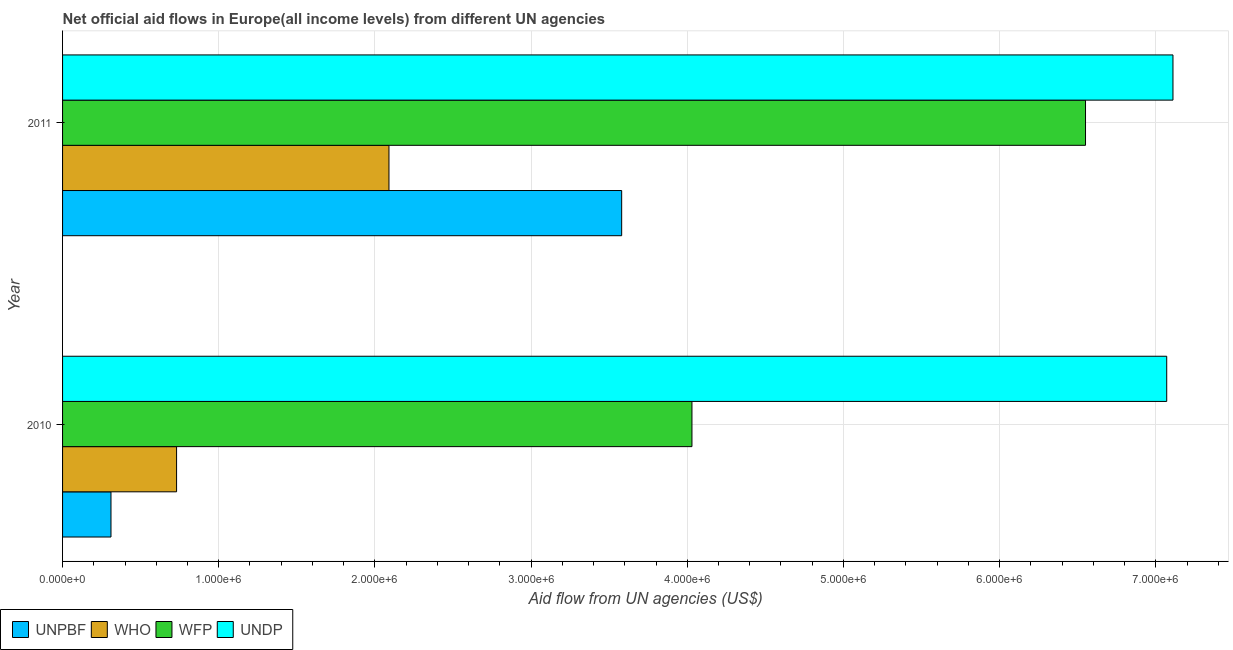How many groups of bars are there?
Your answer should be compact. 2. Are the number of bars per tick equal to the number of legend labels?
Your response must be concise. Yes. Are the number of bars on each tick of the Y-axis equal?
Offer a terse response. Yes. How many bars are there on the 2nd tick from the top?
Your answer should be very brief. 4. What is the label of the 1st group of bars from the top?
Your response must be concise. 2011. What is the amount of aid given by undp in 2011?
Your answer should be very brief. 7.11e+06. Across all years, what is the maximum amount of aid given by undp?
Provide a short and direct response. 7.11e+06. Across all years, what is the minimum amount of aid given by undp?
Provide a short and direct response. 7.07e+06. In which year was the amount of aid given by wfp maximum?
Provide a short and direct response. 2011. In which year was the amount of aid given by wfp minimum?
Make the answer very short. 2010. What is the total amount of aid given by unpbf in the graph?
Provide a short and direct response. 3.89e+06. What is the difference between the amount of aid given by who in 2010 and that in 2011?
Give a very brief answer. -1.36e+06. What is the difference between the amount of aid given by unpbf in 2010 and the amount of aid given by who in 2011?
Offer a very short reply. -1.78e+06. What is the average amount of aid given by undp per year?
Offer a terse response. 7.09e+06. In the year 2011, what is the difference between the amount of aid given by wfp and amount of aid given by unpbf?
Provide a short and direct response. 2.97e+06. In how many years, is the amount of aid given by who greater than 6800000 US$?
Make the answer very short. 0. What is the ratio of the amount of aid given by who in 2010 to that in 2011?
Provide a short and direct response. 0.35. Is the amount of aid given by unpbf in 2010 less than that in 2011?
Your response must be concise. Yes. What does the 2nd bar from the top in 2010 represents?
Ensure brevity in your answer.  WFP. What does the 3rd bar from the bottom in 2011 represents?
Your answer should be very brief. WFP. Is it the case that in every year, the sum of the amount of aid given by unpbf and amount of aid given by who is greater than the amount of aid given by wfp?
Give a very brief answer. No. Does the graph contain any zero values?
Your answer should be compact. No. Does the graph contain grids?
Ensure brevity in your answer.  Yes. Where does the legend appear in the graph?
Your answer should be compact. Bottom left. How many legend labels are there?
Make the answer very short. 4. How are the legend labels stacked?
Your answer should be compact. Horizontal. What is the title of the graph?
Offer a terse response. Net official aid flows in Europe(all income levels) from different UN agencies. Does "CO2 damage" appear as one of the legend labels in the graph?
Give a very brief answer. No. What is the label or title of the X-axis?
Provide a short and direct response. Aid flow from UN agencies (US$). What is the Aid flow from UN agencies (US$) in WHO in 2010?
Your response must be concise. 7.30e+05. What is the Aid flow from UN agencies (US$) in WFP in 2010?
Provide a succinct answer. 4.03e+06. What is the Aid flow from UN agencies (US$) in UNDP in 2010?
Your answer should be compact. 7.07e+06. What is the Aid flow from UN agencies (US$) of UNPBF in 2011?
Give a very brief answer. 3.58e+06. What is the Aid flow from UN agencies (US$) in WHO in 2011?
Ensure brevity in your answer.  2.09e+06. What is the Aid flow from UN agencies (US$) in WFP in 2011?
Your answer should be compact. 6.55e+06. What is the Aid flow from UN agencies (US$) of UNDP in 2011?
Keep it short and to the point. 7.11e+06. Across all years, what is the maximum Aid flow from UN agencies (US$) of UNPBF?
Your answer should be compact. 3.58e+06. Across all years, what is the maximum Aid flow from UN agencies (US$) in WHO?
Your answer should be very brief. 2.09e+06. Across all years, what is the maximum Aid flow from UN agencies (US$) of WFP?
Offer a terse response. 6.55e+06. Across all years, what is the maximum Aid flow from UN agencies (US$) in UNDP?
Ensure brevity in your answer.  7.11e+06. Across all years, what is the minimum Aid flow from UN agencies (US$) in WHO?
Make the answer very short. 7.30e+05. Across all years, what is the minimum Aid flow from UN agencies (US$) in WFP?
Ensure brevity in your answer.  4.03e+06. Across all years, what is the minimum Aid flow from UN agencies (US$) in UNDP?
Your answer should be compact. 7.07e+06. What is the total Aid flow from UN agencies (US$) of UNPBF in the graph?
Keep it short and to the point. 3.89e+06. What is the total Aid flow from UN agencies (US$) in WHO in the graph?
Ensure brevity in your answer.  2.82e+06. What is the total Aid flow from UN agencies (US$) in WFP in the graph?
Provide a short and direct response. 1.06e+07. What is the total Aid flow from UN agencies (US$) in UNDP in the graph?
Keep it short and to the point. 1.42e+07. What is the difference between the Aid flow from UN agencies (US$) in UNPBF in 2010 and that in 2011?
Your answer should be very brief. -3.27e+06. What is the difference between the Aid flow from UN agencies (US$) of WHO in 2010 and that in 2011?
Your response must be concise. -1.36e+06. What is the difference between the Aid flow from UN agencies (US$) in WFP in 2010 and that in 2011?
Your answer should be very brief. -2.52e+06. What is the difference between the Aid flow from UN agencies (US$) in UNDP in 2010 and that in 2011?
Provide a short and direct response. -4.00e+04. What is the difference between the Aid flow from UN agencies (US$) of UNPBF in 2010 and the Aid flow from UN agencies (US$) of WHO in 2011?
Keep it short and to the point. -1.78e+06. What is the difference between the Aid flow from UN agencies (US$) of UNPBF in 2010 and the Aid flow from UN agencies (US$) of WFP in 2011?
Ensure brevity in your answer.  -6.24e+06. What is the difference between the Aid flow from UN agencies (US$) of UNPBF in 2010 and the Aid flow from UN agencies (US$) of UNDP in 2011?
Offer a terse response. -6.80e+06. What is the difference between the Aid flow from UN agencies (US$) of WHO in 2010 and the Aid flow from UN agencies (US$) of WFP in 2011?
Your answer should be very brief. -5.82e+06. What is the difference between the Aid flow from UN agencies (US$) in WHO in 2010 and the Aid flow from UN agencies (US$) in UNDP in 2011?
Keep it short and to the point. -6.38e+06. What is the difference between the Aid flow from UN agencies (US$) in WFP in 2010 and the Aid flow from UN agencies (US$) in UNDP in 2011?
Give a very brief answer. -3.08e+06. What is the average Aid flow from UN agencies (US$) of UNPBF per year?
Your answer should be compact. 1.94e+06. What is the average Aid flow from UN agencies (US$) in WHO per year?
Offer a very short reply. 1.41e+06. What is the average Aid flow from UN agencies (US$) in WFP per year?
Provide a succinct answer. 5.29e+06. What is the average Aid flow from UN agencies (US$) in UNDP per year?
Offer a very short reply. 7.09e+06. In the year 2010, what is the difference between the Aid flow from UN agencies (US$) of UNPBF and Aid flow from UN agencies (US$) of WHO?
Make the answer very short. -4.20e+05. In the year 2010, what is the difference between the Aid flow from UN agencies (US$) in UNPBF and Aid flow from UN agencies (US$) in WFP?
Give a very brief answer. -3.72e+06. In the year 2010, what is the difference between the Aid flow from UN agencies (US$) of UNPBF and Aid flow from UN agencies (US$) of UNDP?
Your response must be concise. -6.76e+06. In the year 2010, what is the difference between the Aid flow from UN agencies (US$) in WHO and Aid flow from UN agencies (US$) in WFP?
Offer a terse response. -3.30e+06. In the year 2010, what is the difference between the Aid flow from UN agencies (US$) in WHO and Aid flow from UN agencies (US$) in UNDP?
Your answer should be very brief. -6.34e+06. In the year 2010, what is the difference between the Aid flow from UN agencies (US$) in WFP and Aid flow from UN agencies (US$) in UNDP?
Make the answer very short. -3.04e+06. In the year 2011, what is the difference between the Aid flow from UN agencies (US$) of UNPBF and Aid flow from UN agencies (US$) of WHO?
Offer a very short reply. 1.49e+06. In the year 2011, what is the difference between the Aid flow from UN agencies (US$) of UNPBF and Aid flow from UN agencies (US$) of WFP?
Ensure brevity in your answer.  -2.97e+06. In the year 2011, what is the difference between the Aid flow from UN agencies (US$) in UNPBF and Aid flow from UN agencies (US$) in UNDP?
Offer a very short reply. -3.53e+06. In the year 2011, what is the difference between the Aid flow from UN agencies (US$) in WHO and Aid flow from UN agencies (US$) in WFP?
Your answer should be compact. -4.46e+06. In the year 2011, what is the difference between the Aid flow from UN agencies (US$) in WHO and Aid flow from UN agencies (US$) in UNDP?
Give a very brief answer. -5.02e+06. In the year 2011, what is the difference between the Aid flow from UN agencies (US$) in WFP and Aid flow from UN agencies (US$) in UNDP?
Your answer should be very brief. -5.60e+05. What is the ratio of the Aid flow from UN agencies (US$) of UNPBF in 2010 to that in 2011?
Keep it short and to the point. 0.09. What is the ratio of the Aid flow from UN agencies (US$) of WHO in 2010 to that in 2011?
Provide a short and direct response. 0.35. What is the ratio of the Aid flow from UN agencies (US$) of WFP in 2010 to that in 2011?
Offer a very short reply. 0.62. What is the ratio of the Aid flow from UN agencies (US$) of UNDP in 2010 to that in 2011?
Offer a terse response. 0.99. What is the difference between the highest and the second highest Aid flow from UN agencies (US$) of UNPBF?
Your answer should be very brief. 3.27e+06. What is the difference between the highest and the second highest Aid flow from UN agencies (US$) in WHO?
Offer a terse response. 1.36e+06. What is the difference between the highest and the second highest Aid flow from UN agencies (US$) in WFP?
Provide a succinct answer. 2.52e+06. What is the difference between the highest and the second highest Aid flow from UN agencies (US$) in UNDP?
Provide a succinct answer. 4.00e+04. What is the difference between the highest and the lowest Aid flow from UN agencies (US$) in UNPBF?
Offer a very short reply. 3.27e+06. What is the difference between the highest and the lowest Aid flow from UN agencies (US$) in WHO?
Your response must be concise. 1.36e+06. What is the difference between the highest and the lowest Aid flow from UN agencies (US$) in WFP?
Your response must be concise. 2.52e+06. What is the difference between the highest and the lowest Aid flow from UN agencies (US$) of UNDP?
Your response must be concise. 4.00e+04. 